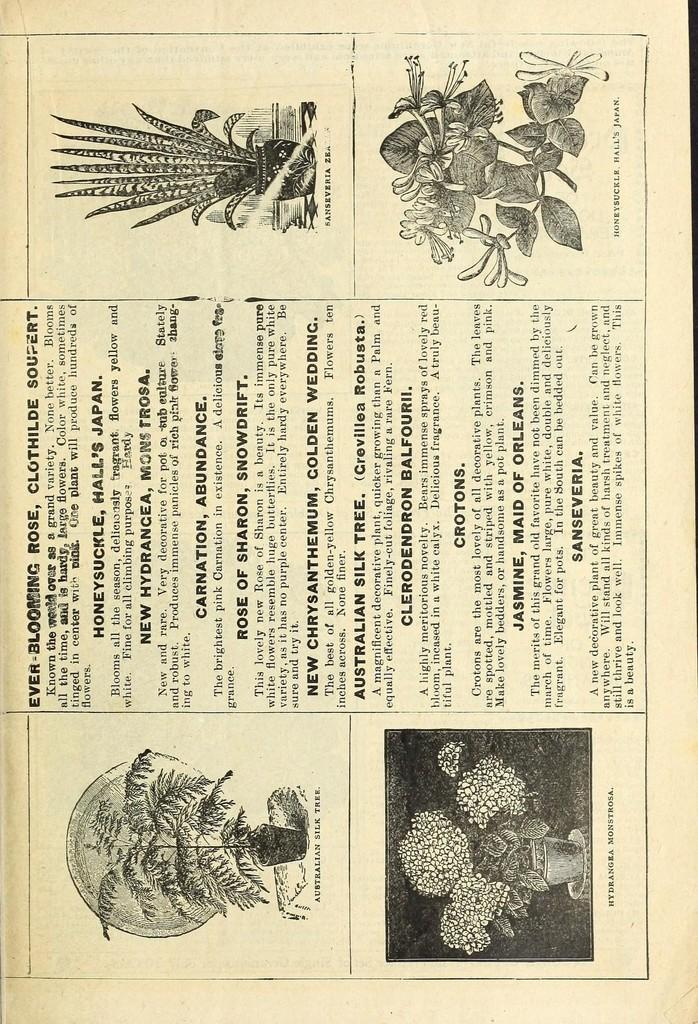What is the main subject of the image? The main subject of the image is a page. What can be found on the page? The page contains house plants and text. What type of flame can be seen near the house plants in the image? There is no flame present in the image; it features a page with house plants and text. What kind of flowers are depicted among the house plants in the image? There are no flowers depicted in the image; it only shows house plants and text on a page. 